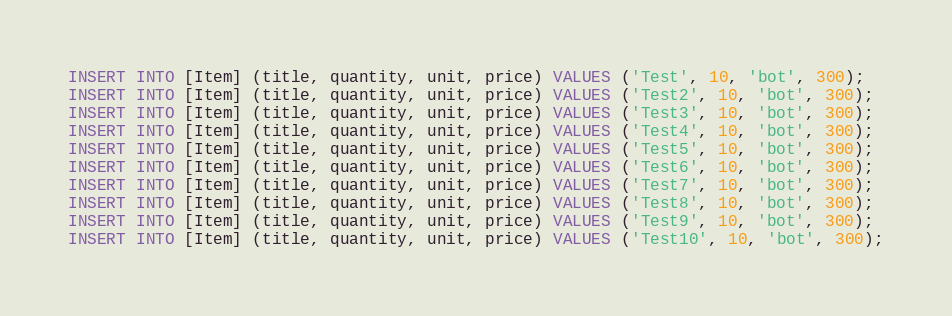Convert code to text. <code><loc_0><loc_0><loc_500><loc_500><_SQL_>INSERT INTO [Item] (title, quantity, unit, price) VALUES ('Test', 10, 'bot', 300);
INSERT INTO [Item] (title, quantity, unit, price) VALUES ('Test2', 10, 'bot', 300);
INSERT INTO [Item] (title, quantity, unit, price) VALUES ('Test3', 10, 'bot', 300);
INSERT INTO [Item] (title, quantity, unit, price) VALUES ('Test4', 10, 'bot', 300);
INSERT INTO [Item] (title, quantity, unit, price) VALUES ('Test5', 10, 'bot', 300);
INSERT INTO [Item] (title, quantity, unit, price) VALUES ('Test6', 10, 'bot', 300);
INSERT INTO [Item] (title, quantity, unit, price) VALUES ('Test7', 10, 'bot', 300);
INSERT INTO [Item] (title, quantity, unit, price) VALUES ('Test8', 10, 'bot', 300);
INSERT INTO [Item] (title, quantity, unit, price) VALUES ('Test9', 10, 'bot', 300);
INSERT INTO [Item] (title, quantity, unit, price) VALUES ('Test10', 10, 'bot', 300);
</code> 